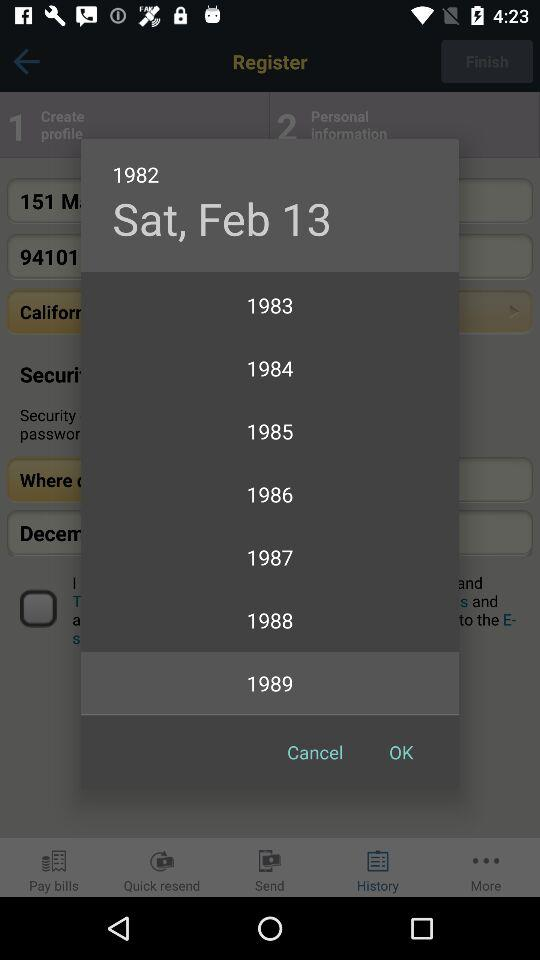What is the selected year? The selected year is 1989. 